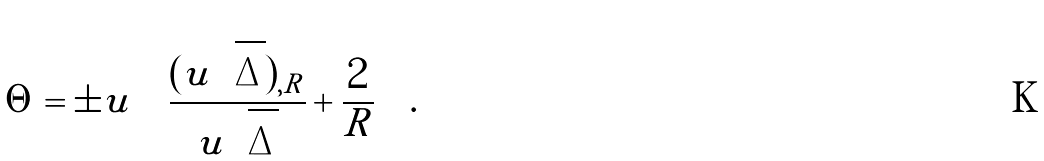<formula> <loc_0><loc_0><loc_500><loc_500>\Theta = \pm u \left [ \frac { ( u \sqrt { \Delta } ) _ { , R } } { u \sqrt { \Delta } } + \frac { 2 } { R } \right ] .</formula> 